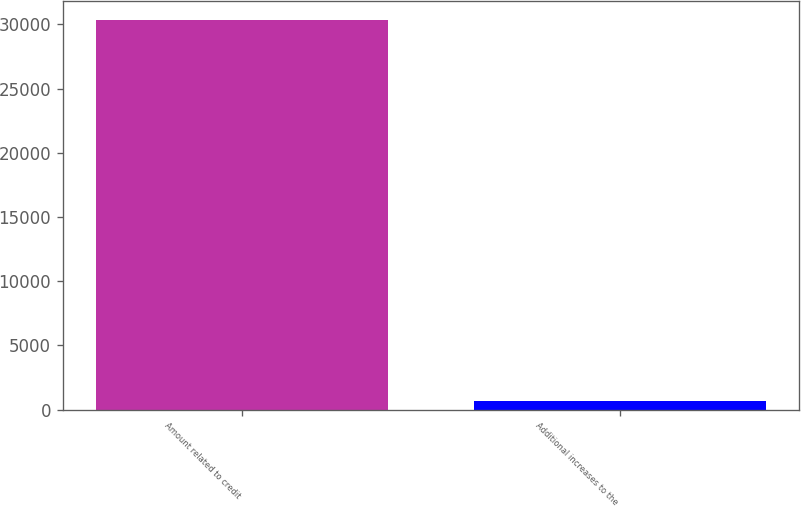Convert chart. <chart><loc_0><loc_0><loc_500><loc_500><bar_chart><fcel>Amount related to credit<fcel>Additional increases to the<nl><fcel>30339.1<fcel>636<nl></chart> 